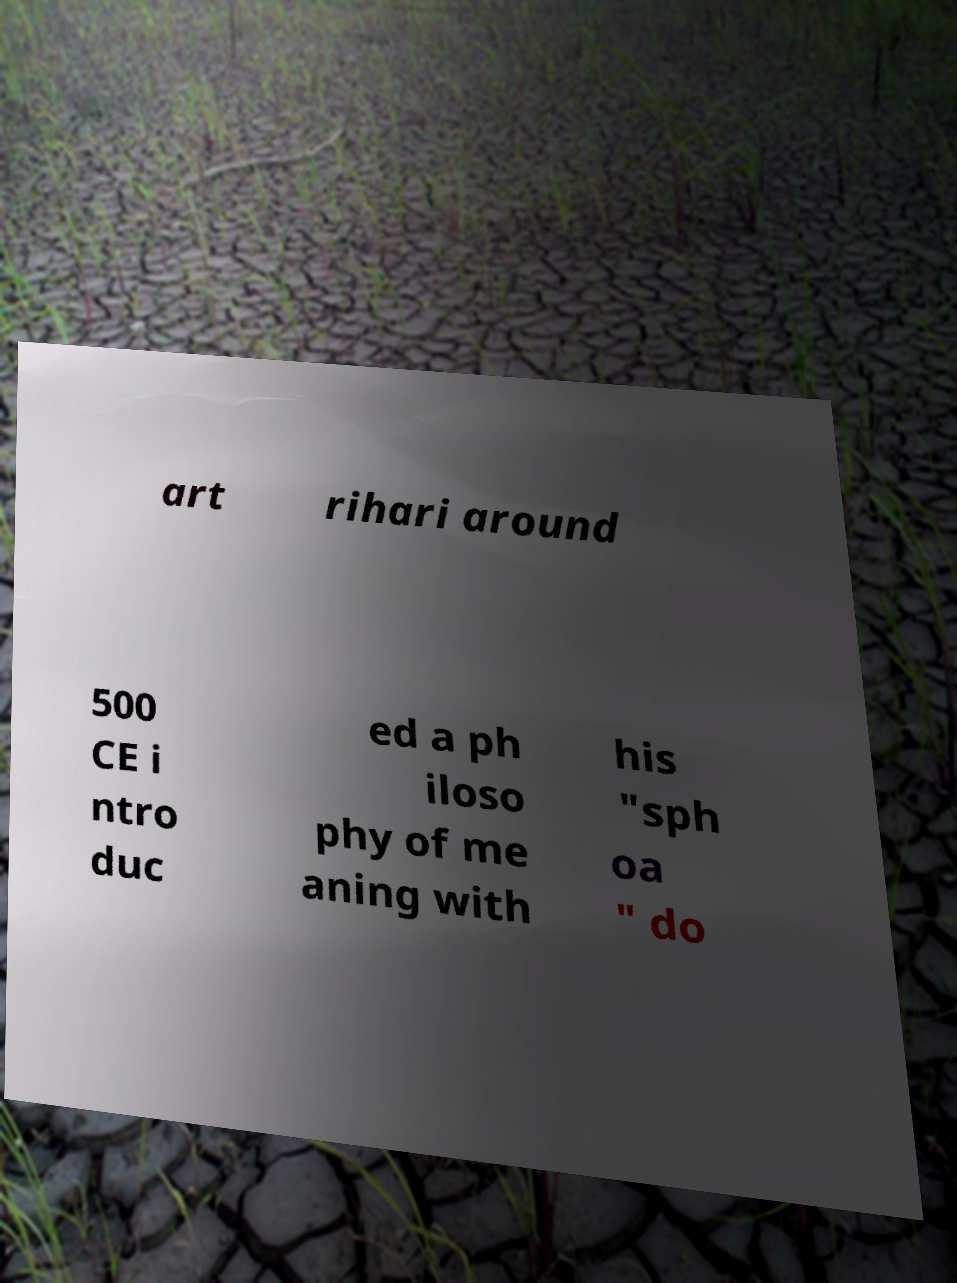Please identify and transcribe the text found in this image. art rihari around 500 CE i ntro duc ed a ph iloso phy of me aning with his "sph oa " do 